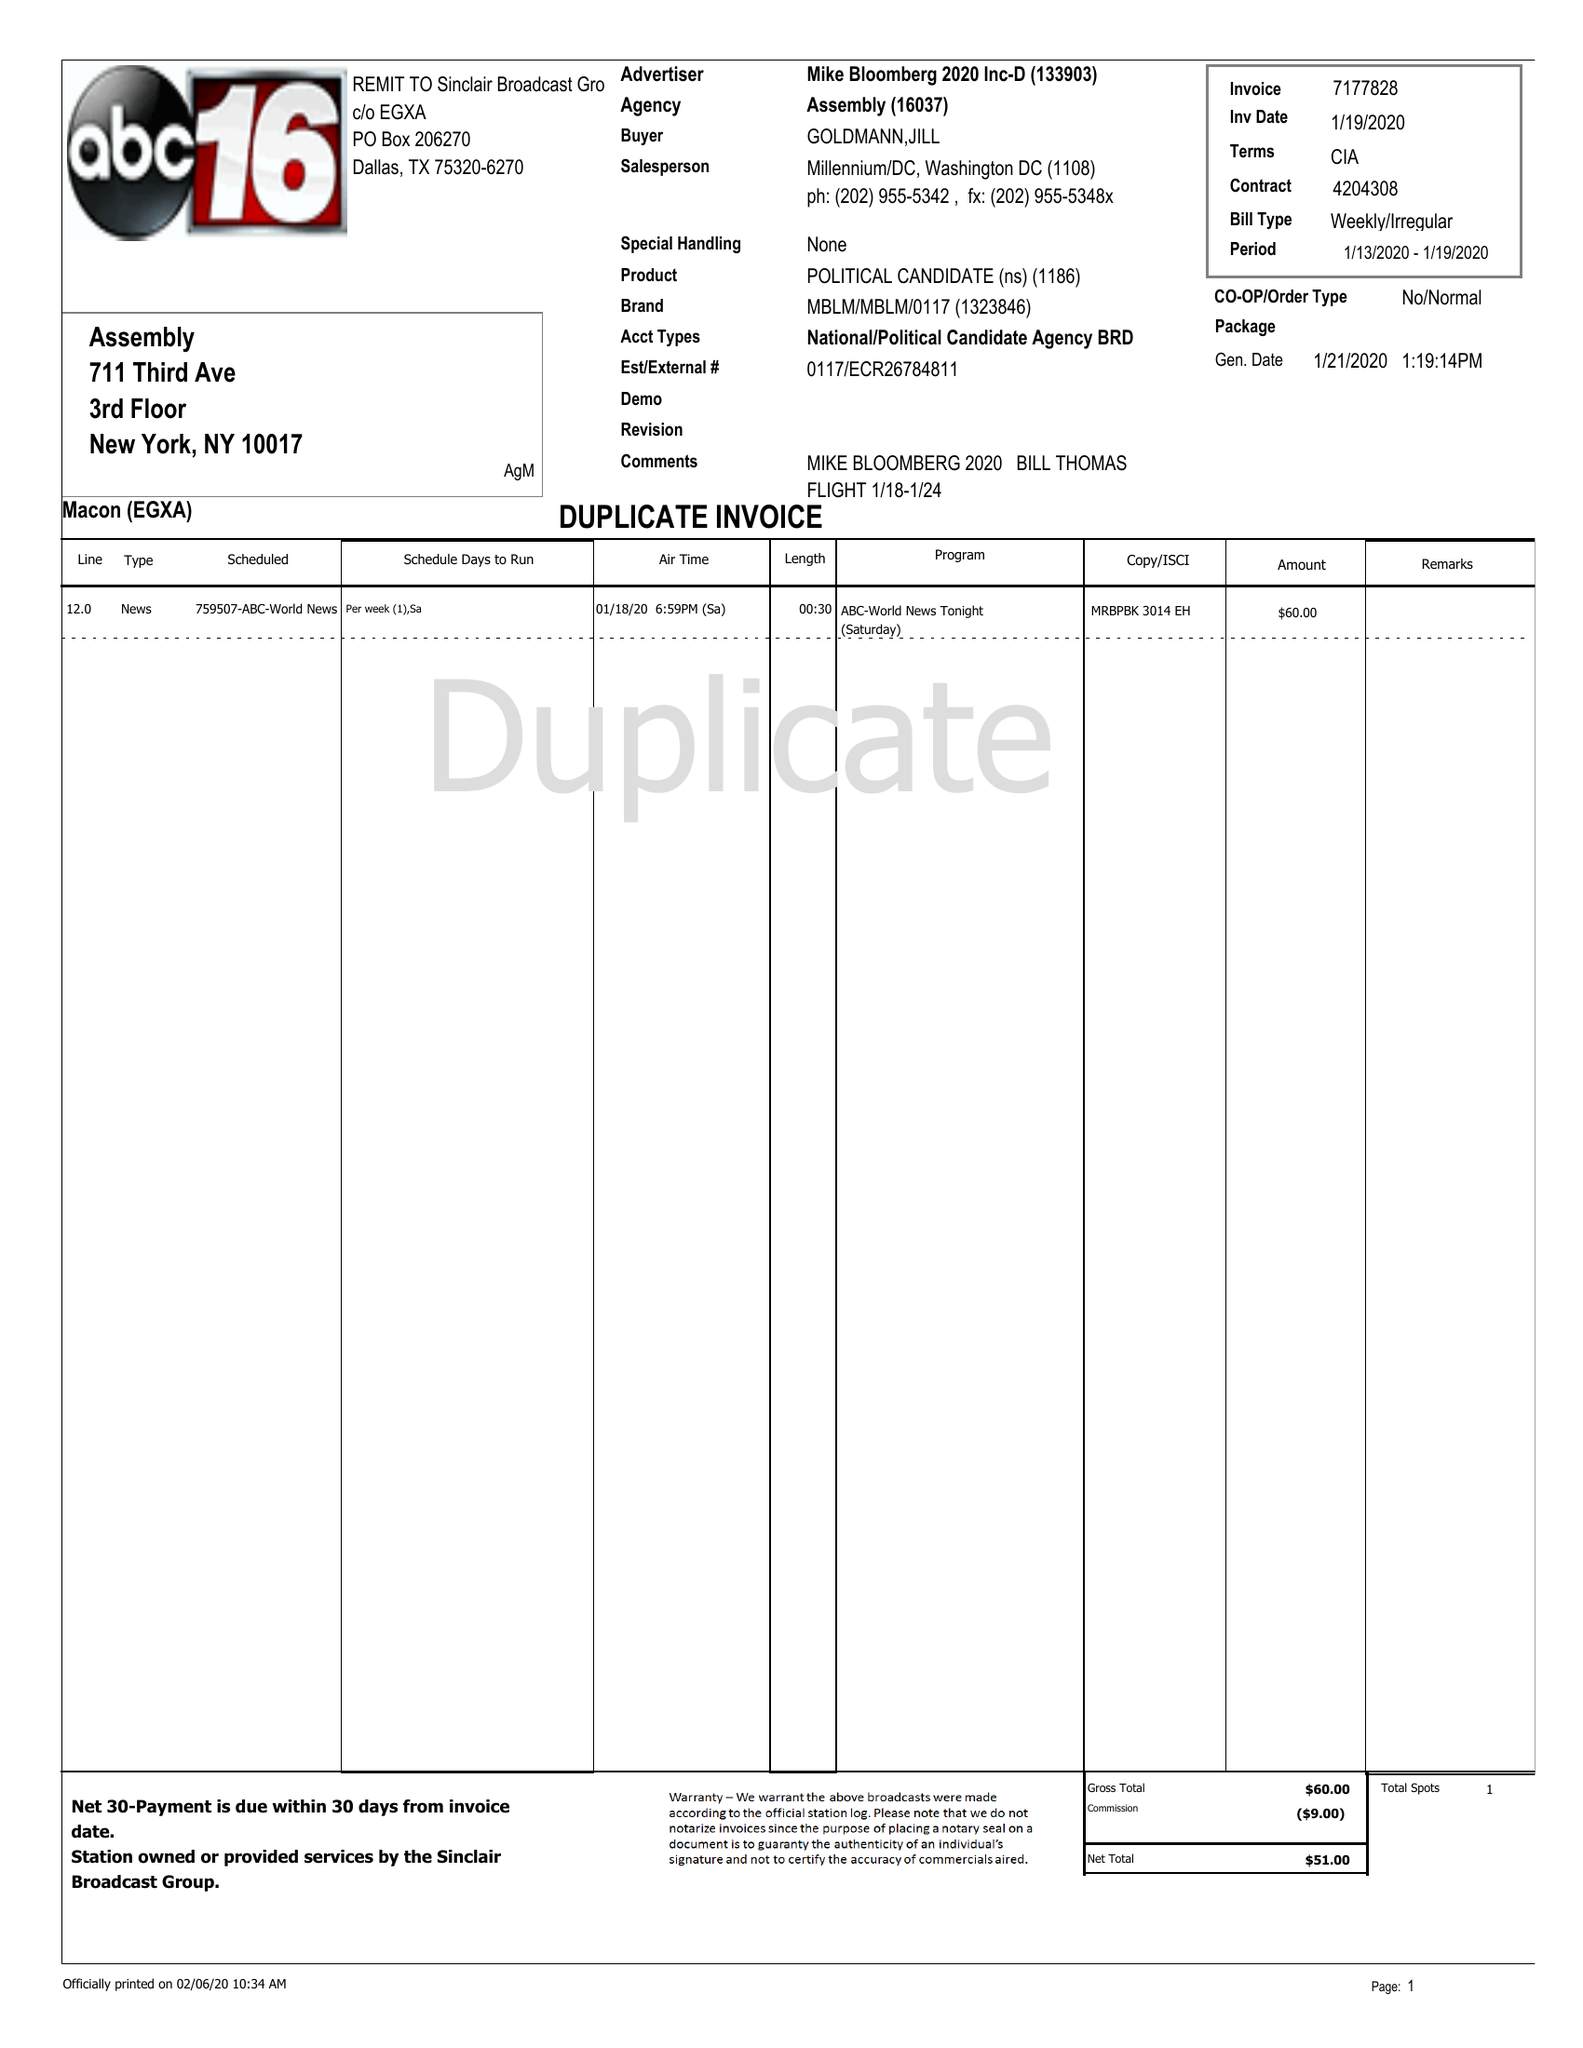What is the value for the flight_to?
Answer the question using a single word or phrase. 01/19/20 